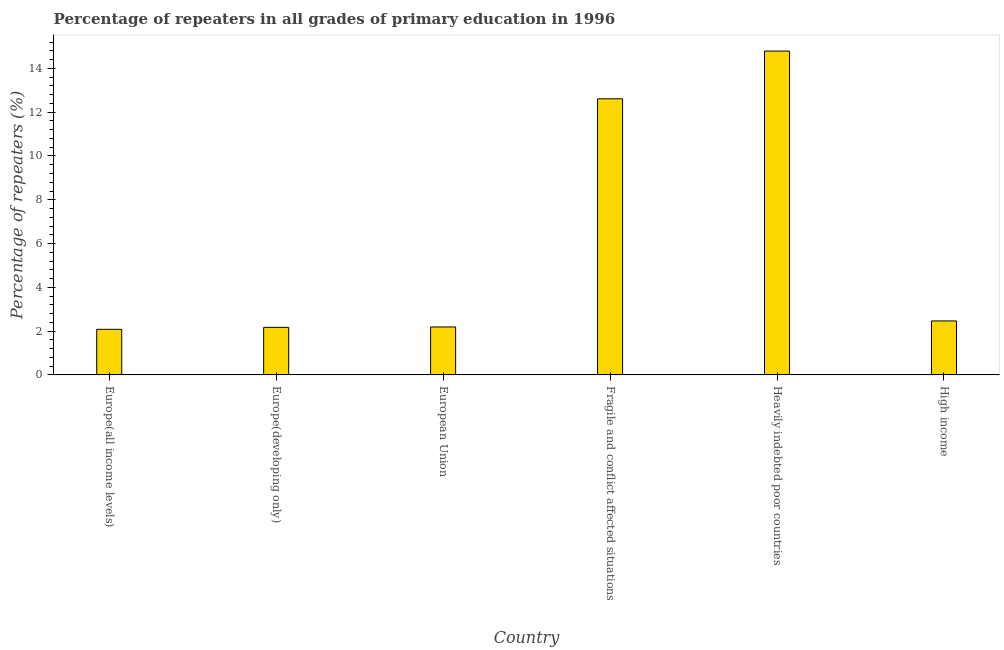Does the graph contain any zero values?
Your response must be concise. No. Does the graph contain grids?
Keep it short and to the point. No. What is the title of the graph?
Offer a terse response. Percentage of repeaters in all grades of primary education in 1996. What is the label or title of the X-axis?
Your answer should be compact. Country. What is the label or title of the Y-axis?
Your answer should be very brief. Percentage of repeaters (%). What is the percentage of repeaters in primary education in High income?
Keep it short and to the point. 2.47. Across all countries, what is the maximum percentage of repeaters in primary education?
Offer a very short reply. 14.79. Across all countries, what is the minimum percentage of repeaters in primary education?
Your answer should be very brief. 2.08. In which country was the percentage of repeaters in primary education maximum?
Provide a short and direct response. Heavily indebted poor countries. In which country was the percentage of repeaters in primary education minimum?
Keep it short and to the point. Europe(all income levels). What is the sum of the percentage of repeaters in primary education?
Make the answer very short. 36.32. What is the difference between the percentage of repeaters in primary education in Europe(all income levels) and High income?
Your answer should be very brief. -0.38. What is the average percentage of repeaters in primary education per country?
Keep it short and to the point. 6.05. What is the median percentage of repeaters in primary education?
Make the answer very short. 2.33. What is the ratio of the percentage of repeaters in primary education in Europe(developing only) to that in Heavily indebted poor countries?
Your answer should be compact. 0.15. Is the difference between the percentage of repeaters in primary education in Europe(all income levels) and High income greater than the difference between any two countries?
Your response must be concise. No. What is the difference between the highest and the second highest percentage of repeaters in primary education?
Your answer should be compact. 2.18. What is the difference between the highest and the lowest percentage of repeaters in primary education?
Make the answer very short. 12.71. In how many countries, is the percentage of repeaters in primary education greater than the average percentage of repeaters in primary education taken over all countries?
Offer a terse response. 2. How many bars are there?
Ensure brevity in your answer.  6. Are all the bars in the graph horizontal?
Your response must be concise. No. How many countries are there in the graph?
Provide a short and direct response. 6. Are the values on the major ticks of Y-axis written in scientific E-notation?
Offer a very short reply. No. What is the Percentage of repeaters (%) of Europe(all income levels)?
Keep it short and to the point. 2.08. What is the Percentage of repeaters (%) of Europe(developing only)?
Ensure brevity in your answer.  2.17. What is the Percentage of repeaters (%) in European Union?
Ensure brevity in your answer.  2.19. What is the Percentage of repeaters (%) of Fragile and conflict affected situations?
Provide a succinct answer. 12.61. What is the Percentage of repeaters (%) in Heavily indebted poor countries?
Your response must be concise. 14.79. What is the Percentage of repeaters (%) of High income?
Provide a succinct answer. 2.47. What is the difference between the Percentage of repeaters (%) in Europe(all income levels) and Europe(developing only)?
Offer a terse response. -0.09. What is the difference between the Percentage of repeaters (%) in Europe(all income levels) and European Union?
Make the answer very short. -0.11. What is the difference between the Percentage of repeaters (%) in Europe(all income levels) and Fragile and conflict affected situations?
Provide a short and direct response. -10.53. What is the difference between the Percentage of repeaters (%) in Europe(all income levels) and Heavily indebted poor countries?
Provide a succinct answer. -12.71. What is the difference between the Percentage of repeaters (%) in Europe(all income levels) and High income?
Your answer should be compact. -0.38. What is the difference between the Percentage of repeaters (%) in Europe(developing only) and European Union?
Give a very brief answer. -0.02. What is the difference between the Percentage of repeaters (%) in Europe(developing only) and Fragile and conflict affected situations?
Keep it short and to the point. -10.44. What is the difference between the Percentage of repeaters (%) in Europe(developing only) and Heavily indebted poor countries?
Your answer should be very brief. -12.62. What is the difference between the Percentage of repeaters (%) in Europe(developing only) and High income?
Make the answer very short. -0.29. What is the difference between the Percentage of repeaters (%) in European Union and Fragile and conflict affected situations?
Provide a succinct answer. -10.42. What is the difference between the Percentage of repeaters (%) in European Union and Heavily indebted poor countries?
Provide a succinct answer. -12.6. What is the difference between the Percentage of repeaters (%) in European Union and High income?
Give a very brief answer. -0.28. What is the difference between the Percentage of repeaters (%) in Fragile and conflict affected situations and Heavily indebted poor countries?
Ensure brevity in your answer.  -2.18. What is the difference between the Percentage of repeaters (%) in Fragile and conflict affected situations and High income?
Your answer should be compact. 10.15. What is the difference between the Percentage of repeaters (%) in Heavily indebted poor countries and High income?
Ensure brevity in your answer.  12.33. What is the ratio of the Percentage of repeaters (%) in Europe(all income levels) to that in European Union?
Provide a short and direct response. 0.95. What is the ratio of the Percentage of repeaters (%) in Europe(all income levels) to that in Fragile and conflict affected situations?
Give a very brief answer. 0.17. What is the ratio of the Percentage of repeaters (%) in Europe(all income levels) to that in Heavily indebted poor countries?
Your answer should be compact. 0.14. What is the ratio of the Percentage of repeaters (%) in Europe(all income levels) to that in High income?
Ensure brevity in your answer.  0.84. What is the ratio of the Percentage of repeaters (%) in Europe(developing only) to that in Fragile and conflict affected situations?
Your response must be concise. 0.17. What is the ratio of the Percentage of repeaters (%) in Europe(developing only) to that in Heavily indebted poor countries?
Offer a terse response. 0.15. What is the ratio of the Percentage of repeaters (%) in Europe(developing only) to that in High income?
Provide a short and direct response. 0.88. What is the ratio of the Percentage of repeaters (%) in European Union to that in Fragile and conflict affected situations?
Your answer should be compact. 0.17. What is the ratio of the Percentage of repeaters (%) in European Union to that in Heavily indebted poor countries?
Provide a succinct answer. 0.15. What is the ratio of the Percentage of repeaters (%) in European Union to that in High income?
Make the answer very short. 0.89. What is the ratio of the Percentage of repeaters (%) in Fragile and conflict affected situations to that in Heavily indebted poor countries?
Keep it short and to the point. 0.85. What is the ratio of the Percentage of repeaters (%) in Fragile and conflict affected situations to that in High income?
Your answer should be very brief. 5.12. What is the ratio of the Percentage of repeaters (%) in Heavily indebted poor countries to that in High income?
Your answer should be compact. 6. 